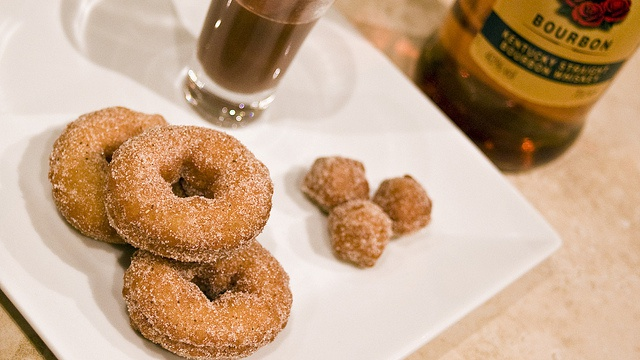Describe the objects in this image and their specific colors. I can see dining table in lightgray, tan, and olive tones, bottle in lightgray, olive, black, and maroon tones, donut in lightgray, tan, brown, and orange tones, donut in lightgray, tan, brown, and orange tones, and cup in lightgray, maroon, gray, and tan tones in this image. 